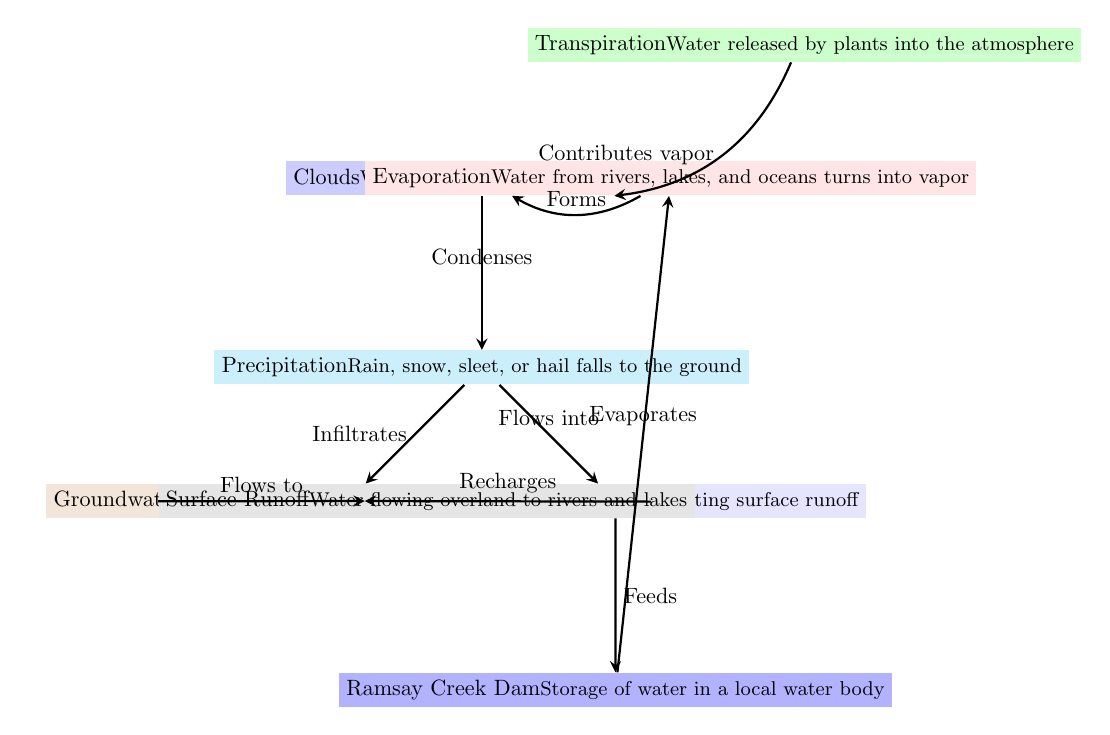What are the two main outputs from the clouds according to the diagram? The diagram indicates two main outputs from the clouds: one is precipitation, which is illustrated as rain, snow, sleet, or hail falling to the ground, and the other is vapor that is influenced by evaporation and transpiration.
Answer: precipitation and vapor How does precipitation affect the river? The diagram shows a direct flow from precipitation to the Charters Towers River, indicating that precipitation flows into the river, contributing to its volume.
Answer: Flows into What is the role of transpiration in the water cycle? Transpiration involves the release of water by plants into the atmosphere, which contributes to the water vapor in the air, thereby influencing cloud formation as indicated in the diagram.
Answer: Contributes vapor From which bodies does water evaporate to form clouds? The diagram's arrows illustrate that water vapor forms clouds primarily from two sources: evaporation from lakes and rivers, specifically the Ramsay Creek Dam and the Charters Towers River.
Answer: rivers and lakes How does surface runoff reach the river? The diagram indicates that surface runoff flows overland toward the Charters Towers River, meaning that water from surfaces gathers and moves directly into the river.
Answer: Flows to What happens to the water after it precipitates? Once precipitation occurs, it either flows into the Charters Towers River or infiltrates into the groundwater, as the diagram shows with arrows pointing towards these two outcomes.
Answer: Flows into the river or infiltrates into groundwater In the context of the diagram, how does groundwater benefit the river? The diagram illustrates a flow where groundwater recharges the river, indicating that water seeping into the soil eventually contributes to the river's water levels.
Answer: Recharges What is one way water from the Ramsay Creek Dam is lost back into the atmosphere? The diagram notes that water from the Ramsay Creek Dam evaporates, which signifies that it transforms back into vapor and contributes to cloud formation.
Answer: Evaporates How many arrows are there indicating flows in the diagram? By counting all the directional arrows representing flows or relationships in the diagram, there are a total of 8 arrows connecting different water cycle elements together.
Answer: 8 